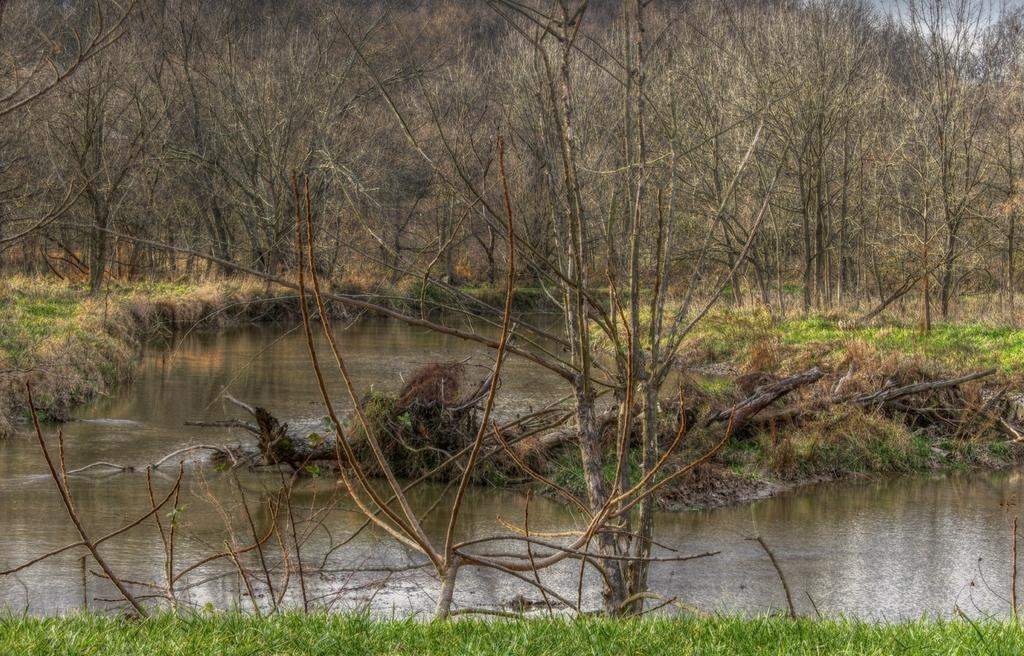What type of vegetation can be seen in the image? There are trees in the image. What natural element is also visible in the image? There is water visible in the image. What type of ground cover is present in the image? There is grass in the image. How many pies are balanced on the branches of the trees in the image? There are no pies present in the image; it features trees, water, and grass. What type of space vehicle can be seen in the image? There is no space vehicle present in the image; it features trees, water, and grass. 